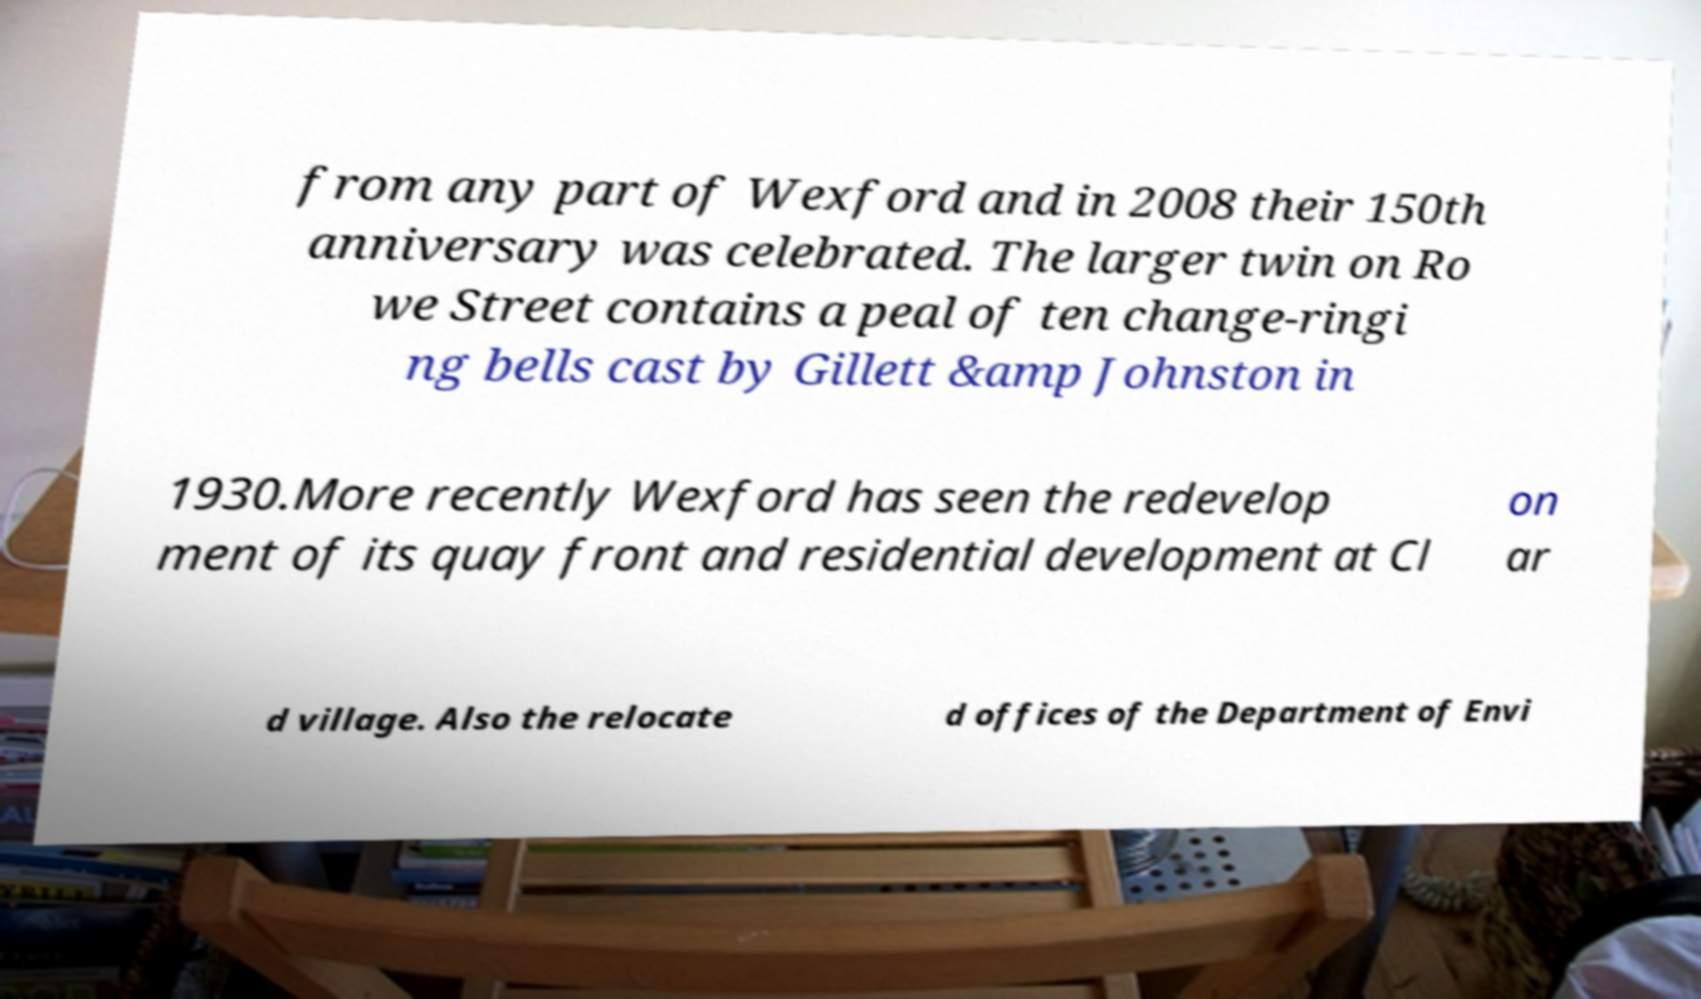Please read and relay the text visible in this image. What does it say? from any part of Wexford and in 2008 their 150th anniversary was celebrated. The larger twin on Ro we Street contains a peal of ten change-ringi ng bells cast by Gillett &amp Johnston in 1930.More recently Wexford has seen the redevelop ment of its quay front and residential development at Cl on ar d village. Also the relocate d offices of the Department of Envi 